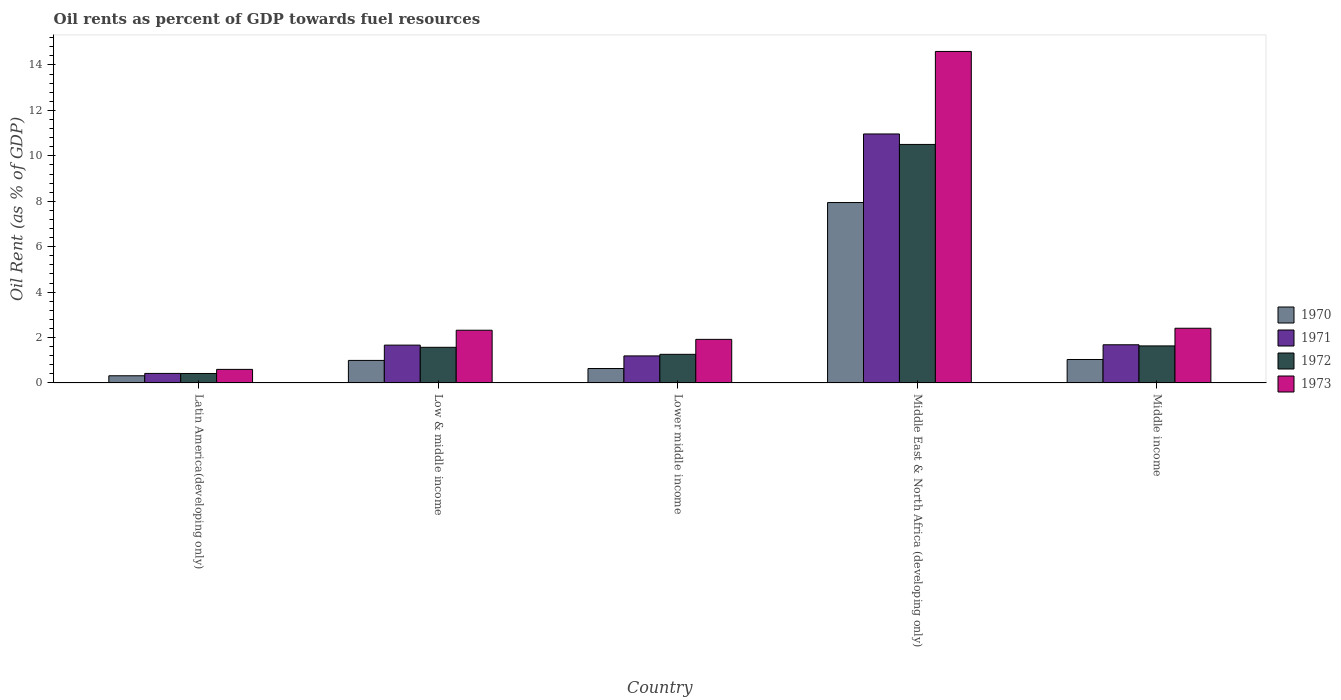How many different coloured bars are there?
Ensure brevity in your answer.  4. Are the number of bars per tick equal to the number of legend labels?
Provide a succinct answer. Yes. Are the number of bars on each tick of the X-axis equal?
Ensure brevity in your answer.  Yes. How many bars are there on the 3rd tick from the left?
Provide a succinct answer. 4. How many bars are there on the 5th tick from the right?
Ensure brevity in your answer.  4. What is the label of the 2nd group of bars from the left?
Your answer should be compact. Low & middle income. What is the oil rent in 1970 in Lower middle income?
Your response must be concise. 0.63. Across all countries, what is the maximum oil rent in 1972?
Keep it short and to the point. 10.5. Across all countries, what is the minimum oil rent in 1971?
Offer a terse response. 0.42. In which country was the oil rent in 1973 maximum?
Provide a short and direct response. Middle East & North Africa (developing only). In which country was the oil rent in 1971 minimum?
Give a very brief answer. Latin America(developing only). What is the total oil rent in 1970 in the graph?
Your response must be concise. 10.92. What is the difference between the oil rent in 1973 in Lower middle income and that in Middle income?
Offer a terse response. -0.49. What is the difference between the oil rent in 1971 in Middle East & North Africa (developing only) and the oil rent in 1972 in Latin America(developing only)?
Ensure brevity in your answer.  10.55. What is the average oil rent in 1972 per country?
Your answer should be very brief. 3.08. What is the difference between the oil rent of/in 1971 and oil rent of/in 1972 in Latin America(developing only)?
Offer a terse response. 0. What is the ratio of the oil rent in 1973 in Lower middle income to that in Middle income?
Give a very brief answer. 0.8. Is the difference between the oil rent in 1971 in Low & middle income and Middle East & North Africa (developing only) greater than the difference between the oil rent in 1972 in Low & middle income and Middle East & North Africa (developing only)?
Make the answer very short. No. What is the difference between the highest and the second highest oil rent in 1971?
Your answer should be very brief. -9.28. What is the difference between the highest and the lowest oil rent in 1973?
Your answer should be very brief. 14. What does the 1st bar from the right in Middle East & North Africa (developing only) represents?
Give a very brief answer. 1973. Are all the bars in the graph horizontal?
Your response must be concise. No. Does the graph contain any zero values?
Your response must be concise. No. Where does the legend appear in the graph?
Your answer should be very brief. Center right. How are the legend labels stacked?
Ensure brevity in your answer.  Vertical. What is the title of the graph?
Offer a terse response. Oil rents as percent of GDP towards fuel resources. Does "2003" appear as one of the legend labels in the graph?
Keep it short and to the point. No. What is the label or title of the Y-axis?
Offer a very short reply. Oil Rent (as % of GDP). What is the Oil Rent (as % of GDP) of 1970 in Latin America(developing only)?
Your answer should be very brief. 0.32. What is the Oil Rent (as % of GDP) of 1971 in Latin America(developing only)?
Your response must be concise. 0.42. What is the Oil Rent (as % of GDP) in 1972 in Latin America(developing only)?
Offer a terse response. 0.42. What is the Oil Rent (as % of GDP) of 1973 in Latin America(developing only)?
Make the answer very short. 0.6. What is the Oil Rent (as % of GDP) in 1970 in Low & middle income?
Provide a succinct answer. 0.99. What is the Oil Rent (as % of GDP) in 1971 in Low & middle income?
Your response must be concise. 1.67. What is the Oil Rent (as % of GDP) of 1972 in Low & middle income?
Keep it short and to the point. 1.57. What is the Oil Rent (as % of GDP) of 1973 in Low & middle income?
Your response must be concise. 2.32. What is the Oil Rent (as % of GDP) of 1970 in Lower middle income?
Provide a short and direct response. 0.63. What is the Oil Rent (as % of GDP) in 1971 in Lower middle income?
Provide a short and direct response. 1.19. What is the Oil Rent (as % of GDP) of 1972 in Lower middle income?
Give a very brief answer. 1.26. What is the Oil Rent (as % of GDP) of 1973 in Lower middle income?
Offer a terse response. 1.92. What is the Oil Rent (as % of GDP) in 1970 in Middle East & North Africa (developing only)?
Your response must be concise. 7.94. What is the Oil Rent (as % of GDP) in 1971 in Middle East & North Africa (developing only)?
Make the answer very short. 10.96. What is the Oil Rent (as % of GDP) of 1972 in Middle East & North Africa (developing only)?
Offer a very short reply. 10.5. What is the Oil Rent (as % of GDP) in 1973 in Middle East & North Africa (developing only)?
Offer a terse response. 14.6. What is the Oil Rent (as % of GDP) in 1970 in Middle income?
Make the answer very short. 1.03. What is the Oil Rent (as % of GDP) of 1971 in Middle income?
Give a very brief answer. 1.68. What is the Oil Rent (as % of GDP) in 1972 in Middle income?
Give a very brief answer. 1.63. What is the Oil Rent (as % of GDP) of 1973 in Middle income?
Make the answer very short. 2.41. Across all countries, what is the maximum Oil Rent (as % of GDP) in 1970?
Your response must be concise. 7.94. Across all countries, what is the maximum Oil Rent (as % of GDP) in 1971?
Your answer should be compact. 10.96. Across all countries, what is the maximum Oil Rent (as % of GDP) in 1972?
Offer a terse response. 10.5. Across all countries, what is the maximum Oil Rent (as % of GDP) in 1973?
Offer a very short reply. 14.6. Across all countries, what is the minimum Oil Rent (as % of GDP) of 1970?
Offer a terse response. 0.32. Across all countries, what is the minimum Oil Rent (as % of GDP) in 1971?
Give a very brief answer. 0.42. Across all countries, what is the minimum Oil Rent (as % of GDP) of 1972?
Offer a terse response. 0.42. Across all countries, what is the minimum Oil Rent (as % of GDP) in 1973?
Your answer should be compact. 0.6. What is the total Oil Rent (as % of GDP) of 1970 in the graph?
Your answer should be very brief. 10.92. What is the total Oil Rent (as % of GDP) of 1971 in the graph?
Ensure brevity in your answer.  15.92. What is the total Oil Rent (as % of GDP) in 1972 in the graph?
Provide a short and direct response. 15.38. What is the total Oil Rent (as % of GDP) of 1973 in the graph?
Offer a very short reply. 21.84. What is the difference between the Oil Rent (as % of GDP) of 1970 in Latin America(developing only) and that in Low & middle income?
Make the answer very short. -0.68. What is the difference between the Oil Rent (as % of GDP) of 1971 in Latin America(developing only) and that in Low & middle income?
Keep it short and to the point. -1.25. What is the difference between the Oil Rent (as % of GDP) of 1972 in Latin America(developing only) and that in Low & middle income?
Your answer should be compact. -1.15. What is the difference between the Oil Rent (as % of GDP) in 1973 in Latin America(developing only) and that in Low & middle income?
Ensure brevity in your answer.  -1.72. What is the difference between the Oil Rent (as % of GDP) of 1970 in Latin America(developing only) and that in Lower middle income?
Your answer should be very brief. -0.32. What is the difference between the Oil Rent (as % of GDP) in 1971 in Latin America(developing only) and that in Lower middle income?
Make the answer very short. -0.77. What is the difference between the Oil Rent (as % of GDP) of 1972 in Latin America(developing only) and that in Lower middle income?
Keep it short and to the point. -0.84. What is the difference between the Oil Rent (as % of GDP) of 1973 in Latin America(developing only) and that in Lower middle income?
Offer a very short reply. -1.32. What is the difference between the Oil Rent (as % of GDP) in 1970 in Latin America(developing only) and that in Middle East & North Africa (developing only)?
Your answer should be compact. -7.63. What is the difference between the Oil Rent (as % of GDP) in 1971 in Latin America(developing only) and that in Middle East & North Africa (developing only)?
Your response must be concise. -10.54. What is the difference between the Oil Rent (as % of GDP) in 1972 in Latin America(developing only) and that in Middle East & North Africa (developing only)?
Offer a terse response. -10.09. What is the difference between the Oil Rent (as % of GDP) in 1973 in Latin America(developing only) and that in Middle East & North Africa (developing only)?
Ensure brevity in your answer.  -14. What is the difference between the Oil Rent (as % of GDP) of 1970 in Latin America(developing only) and that in Middle income?
Your answer should be compact. -0.72. What is the difference between the Oil Rent (as % of GDP) of 1971 in Latin America(developing only) and that in Middle income?
Offer a very short reply. -1.26. What is the difference between the Oil Rent (as % of GDP) of 1972 in Latin America(developing only) and that in Middle income?
Keep it short and to the point. -1.21. What is the difference between the Oil Rent (as % of GDP) of 1973 in Latin America(developing only) and that in Middle income?
Your response must be concise. -1.81. What is the difference between the Oil Rent (as % of GDP) of 1970 in Low & middle income and that in Lower middle income?
Give a very brief answer. 0.36. What is the difference between the Oil Rent (as % of GDP) in 1971 in Low & middle income and that in Lower middle income?
Your response must be concise. 0.48. What is the difference between the Oil Rent (as % of GDP) in 1972 in Low & middle income and that in Lower middle income?
Provide a short and direct response. 0.31. What is the difference between the Oil Rent (as % of GDP) of 1973 in Low & middle income and that in Lower middle income?
Your answer should be compact. 0.4. What is the difference between the Oil Rent (as % of GDP) of 1970 in Low & middle income and that in Middle East & North Africa (developing only)?
Offer a terse response. -6.95. What is the difference between the Oil Rent (as % of GDP) in 1971 in Low & middle income and that in Middle East & North Africa (developing only)?
Make the answer very short. -9.3. What is the difference between the Oil Rent (as % of GDP) in 1972 in Low & middle income and that in Middle East & North Africa (developing only)?
Your answer should be very brief. -8.93. What is the difference between the Oil Rent (as % of GDP) in 1973 in Low & middle income and that in Middle East & North Africa (developing only)?
Make the answer very short. -12.28. What is the difference between the Oil Rent (as % of GDP) in 1970 in Low & middle income and that in Middle income?
Your response must be concise. -0.04. What is the difference between the Oil Rent (as % of GDP) of 1971 in Low & middle income and that in Middle income?
Keep it short and to the point. -0.01. What is the difference between the Oil Rent (as % of GDP) of 1972 in Low & middle income and that in Middle income?
Your response must be concise. -0.06. What is the difference between the Oil Rent (as % of GDP) of 1973 in Low & middle income and that in Middle income?
Keep it short and to the point. -0.09. What is the difference between the Oil Rent (as % of GDP) in 1970 in Lower middle income and that in Middle East & North Africa (developing only)?
Your answer should be compact. -7.31. What is the difference between the Oil Rent (as % of GDP) in 1971 in Lower middle income and that in Middle East & North Africa (developing only)?
Your answer should be compact. -9.77. What is the difference between the Oil Rent (as % of GDP) of 1972 in Lower middle income and that in Middle East & North Africa (developing only)?
Make the answer very short. -9.24. What is the difference between the Oil Rent (as % of GDP) in 1973 in Lower middle income and that in Middle East & North Africa (developing only)?
Give a very brief answer. -12.68. What is the difference between the Oil Rent (as % of GDP) in 1970 in Lower middle income and that in Middle income?
Your answer should be very brief. -0.4. What is the difference between the Oil Rent (as % of GDP) of 1971 in Lower middle income and that in Middle income?
Offer a very short reply. -0.49. What is the difference between the Oil Rent (as % of GDP) of 1972 in Lower middle income and that in Middle income?
Provide a succinct answer. -0.37. What is the difference between the Oil Rent (as % of GDP) of 1973 in Lower middle income and that in Middle income?
Your answer should be compact. -0.49. What is the difference between the Oil Rent (as % of GDP) of 1970 in Middle East & North Africa (developing only) and that in Middle income?
Provide a short and direct response. 6.91. What is the difference between the Oil Rent (as % of GDP) of 1971 in Middle East & North Africa (developing only) and that in Middle income?
Ensure brevity in your answer.  9.28. What is the difference between the Oil Rent (as % of GDP) of 1972 in Middle East & North Africa (developing only) and that in Middle income?
Provide a succinct answer. 8.87. What is the difference between the Oil Rent (as % of GDP) in 1973 in Middle East & North Africa (developing only) and that in Middle income?
Give a very brief answer. 12.19. What is the difference between the Oil Rent (as % of GDP) in 1970 in Latin America(developing only) and the Oil Rent (as % of GDP) in 1971 in Low & middle income?
Provide a short and direct response. -1.35. What is the difference between the Oil Rent (as % of GDP) in 1970 in Latin America(developing only) and the Oil Rent (as % of GDP) in 1972 in Low & middle income?
Your answer should be very brief. -1.25. What is the difference between the Oil Rent (as % of GDP) in 1970 in Latin America(developing only) and the Oil Rent (as % of GDP) in 1973 in Low & middle income?
Your answer should be compact. -2.01. What is the difference between the Oil Rent (as % of GDP) in 1971 in Latin America(developing only) and the Oil Rent (as % of GDP) in 1972 in Low & middle income?
Your response must be concise. -1.15. What is the difference between the Oil Rent (as % of GDP) of 1971 in Latin America(developing only) and the Oil Rent (as % of GDP) of 1973 in Low & middle income?
Provide a succinct answer. -1.9. What is the difference between the Oil Rent (as % of GDP) of 1972 in Latin America(developing only) and the Oil Rent (as % of GDP) of 1973 in Low & middle income?
Provide a succinct answer. -1.9. What is the difference between the Oil Rent (as % of GDP) of 1970 in Latin America(developing only) and the Oil Rent (as % of GDP) of 1971 in Lower middle income?
Ensure brevity in your answer.  -0.87. What is the difference between the Oil Rent (as % of GDP) of 1970 in Latin America(developing only) and the Oil Rent (as % of GDP) of 1972 in Lower middle income?
Provide a short and direct response. -0.94. What is the difference between the Oil Rent (as % of GDP) of 1970 in Latin America(developing only) and the Oil Rent (as % of GDP) of 1973 in Lower middle income?
Keep it short and to the point. -1.6. What is the difference between the Oil Rent (as % of GDP) of 1971 in Latin America(developing only) and the Oil Rent (as % of GDP) of 1972 in Lower middle income?
Give a very brief answer. -0.84. What is the difference between the Oil Rent (as % of GDP) in 1971 in Latin America(developing only) and the Oil Rent (as % of GDP) in 1973 in Lower middle income?
Keep it short and to the point. -1.5. What is the difference between the Oil Rent (as % of GDP) of 1972 in Latin America(developing only) and the Oil Rent (as % of GDP) of 1973 in Lower middle income?
Make the answer very short. -1.5. What is the difference between the Oil Rent (as % of GDP) of 1970 in Latin America(developing only) and the Oil Rent (as % of GDP) of 1971 in Middle East & North Africa (developing only)?
Your response must be concise. -10.65. What is the difference between the Oil Rent (as % of GDP) of 1970 in Latin America(developing only) and the Oil Rent (as % of GDP) of 1972 in Middle East & North Africa (developing only)?
Offer a very short reply. -10.19. What is the difference between the Oil Rent (as % of GDP) of 1970 in Latin America(developing only) and the Oil Rent (as % of GDP) of 1973 in Middle East & North Africa (developing only)?
Offer a very short reply. -14.28. What is the difference between the Oil Rent (as % of GDP) of 1971 in Latin America(developing only) and the Oil Rent (as % of GDP) of 1972 in Middle East & North Africa (developing only)?
Your answer should be compact. -10.08. What is the difference between the Oil Rent (as % of GDP) of 1971 in Latin America(developing only) and the Oil Rent (as % of GDP) of 1973 in Middle East & North Africa (developing only)?
Provide a succinct answer. -14.18. What is the difference between the Oil Rent (as % of GDP) in 1972 in Latin America(developing only) and the Oil Rent (as % of GDP) in 1973 in Middle East & North Africa (developing only)?
Provide a short and direct response. -14.18. What is the difference between the Oil Rent (as % of GDP) in 1970 in Latin America(developing only) and the Oil Rent (as % of GDP) in 1971 in Middle income?
Make the answer very short. -1.36. What is the difference between the Oil Rent (as % of GDP) of 1970 in Latin America(developing only) and the Oil Rent (as % of GDP) of 1972 in Middle income?
Your answer should be very brief. -1.32. What is the difference between the Oil Rent (as % of GDP) in 1970 in Latin America(developing only) and the Oil Rent (as % of GDP) in 1973 in Middle income?
Your answer should be very brief. -2.09. What is the difference between the Oil Rent (as % of GDP) of 1971 in Latin America(developing only) and the Oil Rent (as % of GDP) of 1972 in Middle income?
Give a very brief answer. -1.21. What is the difference between the Oil Rent (as % of GDP) of 1971 in Latin America(developing only) and the Oil Rent (as % of GDP) of 1973 in Middle income?
Provide a short and direct response. -1.99. What is the difference between the Oil Rent (as % of GDP) in 1972 in Latin America(developing only) and the Oil Rent (as % of GDP) in 1973 in Middle income?
Make the answer very short. -1.99. What is the difference between the Oil Rent (as % of GDP) in 1970 in Low & middle income and the Oil Rent (as % of GDP) in 1971 in Lower middle income?
Ensure brevity in your answer.  -0.2. What is the difference between the Oil Rent (as % of GDP) of 1970 in Low & middle income and the Oil Rent (as % of GDP) of 1972 in Lower middle income?
Provide a short and direct response. -0.27. What is the difference between the Oil Rent (as % of GDP) in 1970 in Low & middle income and the Oil Rent (as % of GDP) in 1973 in Lower middle income?
Give a very brief answer. -0.93. What is the difference between the Oil Rent (as % of GDP) in 1971 in Low & middle income and the Oil Rent (as % of GDP) in 1972 in Lower middle income?
Offer a very short reply. 0.41. What is the difference between the Oil Rent (as % of GDP) in 1971 in Low & middle income and the Oil Rent (as % of GDP) in 1973 in Lower middle income?
Provide a short and direct response. -0.25. What is the difference between the Oil Rent (as % of GDP) in 1972 in Low & middle income and the Oil Rent (as % of GDP) in 1973 in Lower middle income?
Your answer should be very brief. -0.35. What is the difference between the Oil Rent (as % of GDP) of 1970 in Low & middle income and the Oil Rent (as % of GDP) of 1971 in Middle East & North Africa (developing only)?
Ensure brevity in your answer.  -9.97. What is the difference between the Oil Rent (as % of GDP) in 1970 in Low & middle income and the Oil Rent (as % of GDP) in 1972 in Middle East & North Africa (developing only)?
Your answer should be compact. -9.51. What is the difference between the Oil Rent (as % of GDP) of 1970 in Low & middle income and the Oil Rent (as % of GDP) of 1973 in Middle East & North Africa (developing only)?
Give a very brief answer. -13.6. What is the difference between the Oil Rent (as % of GDP) in 1971 in Low & middle income and the Oil Rent (as % of GDP) in 1972 in Middle East & North Africa (developing only)?
Your answer should be very brief. -8.84. What is the difference between the Oil Rent (as % of GDP) in 1971 in Low & middle income and the Oil Rent (as % of GDP) in 1973 in Middle East & North Africa (developing only)?
Your response must be concise. -12.93. What is the difference between the Oil Rent (as % of GDP) in 1972 in Low & middle income and the Oil Rent (as % of GDP) in 1973 in Middle East & North Africa (developing only)?
Offer a terse response. -13.03. What is the difference between the Oil Rent (as % of GDP) in 1970 in Low & middle income and the Oil Rent (as % of GDP) in 1971 in Middle income?
Your answer should be very brief. -0.69. What is the difference between the Oil Rent (as % of GDP) of 1970 in Low & middle income and the Oil Rent (as % of GDP) of 1972 in Middle income?
Ensure brevity in your answer.  -0.64. What is the difference between the Oil Rent (as % of GDP) of 1970 in Low & middle income and the Oil Rent (as % of GDP) of 1973 in Middle income?
Your answer should be very brief. -1.42. What is the difference between the Oil Rent (as % of GDP) of 1971 in Low & middle income and the Oil Rent (as % of GDP) of 1972 in Middle income?
Offer a very short reply. 0.03. What is the difference between the Oil Rent (as % of GDP) of 1971 in Low & middle income and the Oil Rent (as % of GDP) of 1973 in Middle income?
Ensure brevity in your answer.  -0.74. What is the difference between the Oil Rent (as % of GDP) of 1972 in Low & middle income and the Oil Rent (as % of GDP) of 1973 in Middle income?
Ensure brevity in your answer.  -0.84. What is the difference between the Oil Rent (as % of GDP) in 1970 in Lower middle income and the Oil Rent (as % of GDP) in 1971 in Middle East & North Africa (developing only)?
Provide a succinct answer. -10.33. What is the difference between the Oil Rent (as % of GDP) in 1970 in Lower middle income and the Oil Rent (as % of GDP) in 1972 in Middle East & North Africa (developing only)?
Your answer should be very brief. -9.87. What is the difference between the Oil Rent (as % of GDP) of 1970 in Lower middle income and the Oil Rent (as % of GDP) of 1973 in Middle East & North Africa (developing only)?
Your answer should be compact. -13.96. What is the difference between the Oil Rent (as % of GDP) in 1971 in Lower middle income and the Oil Rent (as % of GDP) in 1972 in Middle East & North Africa (developing only)?
Provide a short and direct response. -9.31. What is the difference between the Oil Rent (as % of GDP) in 1971 in Lower middle income and the Oil Rent (as % of GDP) in 1973 in Middle East & North Africa (developing only)?
Provide a short and direct response. -13.41. What is the difference between the Oil Rent (as % of GDP) of 1972 in Lower middle income and the Oil Rent (as % of GDP) of 1973 in Middle East & North Africa (developing only)?
Ensure brevity in your answer.  -13.34. What is the difference between the Oil Rent (as % of GDP) in 1970 in Lower middle income and the Oil Rent (as % of GDP) in 1971 in Middle income?
Offer a terse response. -1.05. What is the difference between the Oil Rent (as % of GDP) in 1970 in Lower middle income and the Oil Rent (as % of GDP) in 1972 in Middle income?
Provide a short and direct response. -1. What is the difference between the Oil Rent (as % of GDP) in 1970 in Lower middle income and the Oil Rent (as % of GDP) in 1973 in Middle income?
Offer a very short reply. -1.77. What is the difference between the Oil Rent (as % of GDP) in 1971 in Lower middle income and the Oil Rent (as % of GDP) in 1972 in Middle income?
Provide a succinct answer. -0.44. What is the difference between the Oil Rent (as % of GDP) in 1971 in Lower middle income and the Oil Rent (as % of GDP) in 1973 in Middle income?
Make the answer very short. -1.22. What is the difference between the Oil Rent (as % of GDP) in 1972 in Lower middle income and the Oil Rent (as % of GDP) in 1973 in Middle income?
Provide a short and direct response. -1.15. What is the difference between the Oil Rent (as % of GDP) of 1970 in Middle East & North Africa (developing only) and the Oil Rent (as % of GDP) of 1971 in Middle income?
Your response must be concise. 6.26. What is the difference between the Oil Rent (as % of GDP) of 1970 in Middle East & North Africa (developing only) and the Oil Rent (as % of GDP) of 1972 in Middle income?
Your answer should be compact. 6.31. What is the difference between the Oil Rent (as % of GDP) in 1970 in Middle East & North Africa (developing only) and the Oil Rent (as % of GDP) in 1973 in Middle income?
Your response must be concise. 5.53. What is the difference between the Oil Rent (as % of GDP) in 1971 in Middle East & North Africa (developing only) and the Oil Rent (as % of GDP) in 1972 in Middle income?
Give a very brief answer. 9.33. What is the difference between the Oil Rent (as % of GDP) of 1971 in Middle East & North Africa (developing only) and the Oil Rent (as % of GDP) of 1973 in Middle income?
Provide a succinct answer. 8.55. What is the difference between the Oil Rent (as % of GDP) of 1972 in Middle East & North Africa (developing only) and the Oil Rent (as % of GDP) of 1973 in Middle income?
Make the answer very short. 8.09. What is the average Oil Rent (as % of GDP) of 1970 per country?
Your answer should be compact. 2.18. What is the average Oil Rent (as % of GDP) of 1971 per country?
Offer a very short reply. 3.18. What is the average Oil Rent (as % of GDP) of 1972 per country?
Offer a very short reply. 3.08. What is the average Oil Rent (as % of GDP) of 1973 per country?
Keep it short and to the point. 4.37. What is the difference between the Oil Rent (as % of GDP) of 1970 and Oil Rent (as % of GDP) of 1971 in Latin America(developing only)?
Offer a very short reply. -0.1. What is the difference between the Oil Rent (as % of GDP) in 1970 and Oil Rent (as % of GDP) in 1972 in Latin America(developing only)?
Make the answer very short. -0.1. What is the difference between the Oil Rent (as % of GDP) of 1970 and Oil Rent (as % of GDP) of 1973 in Latin America(developing only)?
Your answer should be compact. -0.28. What is the difference between the Oil Rent (as % of GDP) in 1971 and Oil Rent (as % of GDP) in 1972 in Latin America(developing only)?
Make the answer very short. 0. What is the difference between the Oil Rent (as % of GDP) of 1971 and Oil Rent (as % of GDP) of 1973 in Latin America(developing only)?
Make the answer very short. -0.18. What is the difference between the Oil Rent (as % of GDP) in 1972 and Oil Rent (as % of GDP) in 1973 in Latin America(developing only)?
Your answer should be very brief. -0.18. What is the difference between the Oil Rent (as % of GDP) in 1970 and Oil Rent (as % of GDP) in 1971 in Low & middle income?
Provide a short and direct response. -0.67. What is the difference between the Oil Rent (as % of GDP) in 1970 and Oil Rent (as % of GDP) in 1972 in Low & middle income?
Ensure brevity in your answer.  -0.58. What is the difference between the Oil Rent (as % of GDP) of 1970 and Oil Rent (as % of GDP) of 1973 in Low & middle income?
Offer a very short reply. -1.33. What is the difference between the Oil Rent (as % of GDP) in 1971 and Oil Rent (as % of GDP) in 1972 in Low & middle income?
Your answer should be compact. 0.1. What is the difference between the Oil Rent (as % of GDP) in 1971 and Oil Rent (as % of GDP) in 1973 in Low & middle income?
Your response must be concise. -0.66. What is the difference between the Oil Rent (as % of GDP) of 1972 and Oil Rent (as % of GDP) of 1973 in Low & middle income?
Keep it short and to the point. -0.75. What is the difference between the Oil Rent (as % of GDP) of 1970 and Oil Rent (as % of GDP) of 1971 in Lower middle income?
Your answer should be compact. -0.56. What is the difference between the Oil Rent (as % of GDP) in 1970 and Oil Rent (as % of GDP) in 1972 in Lower middle income?
Provide a succinct answer. -0.62. What is the difference between the Oil Rent (as % of GDP) of 1970 and Oil Rent (as % of GDP) of 1973 in Lower middle income?
Your answer should be very brief. -1.28. What is the difference between the Oil Rent (as % of GDP) in 1971 and Oil Rent (as % of GDP) in 1972 in Lower middle income?
Provide a short and direct response. -0.07. What is the difference between the Oil Rent (as % of GDP) in 1971 and Oil Rent (as % of GDP) in 1973 in Lower middle income?
Your response must be concise. -0.73. What is the difference between the Oil Rent (as % of GDP) of 1972 and Oil Rent (as % of GDP) of 1973 in Lower middle income?
Offer a terse response. -0.66. What is the difference between the Oil Rent (as % of GDP) in 1970 and Oil Rent (as % of GDP) in 1971 in Middle East & North Africa (developing only)?
Your response must be concise. -3.02. What is the difference between the Oil Rent (as % of GDP) of 1970 and Oil Rent (as % of GDP) of 1972 in Middle East & North Africa (developing only)?
Keep it short and to the point. -2.56. What is the difference between the Oil Rent (as % of GDP) in 1970 and Oil Rent (as % of GDP) in 1973 in Middle East & North Africa (developing only)?
Give a very brief answer. -6.65. What is the difference between the Oil Rent (as % of GDP) in 1971 and Oil Rent (as % of GDP) in 1972 in Middle East & North Africa (developing only)?
Your answer should be compact. 0.46. What is the difference between the Oil Rent (as % of GDP) of 1971 and Oil Rent (as % of GDP) of 1973 in Middle East & North Africa (developing only)?
Provide a short and direct response. -3.63. What is the difference between the Oil Rent (as % of GDP) in 1972 and Oil Rent (as % of GDP) in 1973 in Middle East & North Africa (developing only)?
Keep it short and to the point. -4.09. What is the difference between the Oil Rent (as % of GDP) of 1970 and Oil Rent (as % of GDP) of 1971 in Middle income?
Provide a succinct answer. -0.65. What is the difference between the Oil Rent (as % of GDP) of 1970 and Oil Rent (as % of GDP) of 1972 in Middle income?
Ensure brevity in your answer.  -0.6. What is the difference between the Oil Rent (as % of GDP) in 1970 and Oil Rent (as % of GDP) in 1973 in Middle income?
Keep it short and to the point. -1.38. What is the difference between the Oil Rent (as % of GDP) of 1971 and Oil Rent (as % of GDP) of 1972 in Middle income?
Provide a short and direct response. 0.05. What is the difference between the Oil Rent (as % of GDP) in 1971 and Oil Rent (as % of GDP) in 1973 in Middle income?
Make the answer very short. -0.73. What is the difference between the Oil Rent (as % of GDP) in 1972 and Oil Rent (as % of GDP) in 1973 in Middle income?
Your response must be concise. -0.78. What is the ratio of the Oil Rent (as % of GDP) in 1970 in Latin America(developing only) to that in Low & middle income?
Keep it short and to the point. 0.32. What is the ratio of the Oil Rent (as % of GDP) in 1971 in Latin America(developing only) to that in Low & middle income?
Give a very brief answer. 0.25. What is the ratio of the Oil Rent (as % of GDP) in 1972 in Latin America(developing only) to that in Low & middle income?
Make the answer very short. 0.27. What is the ratio of the Oil Rent (as % of GDP) of 1973 in Latin America(developing only) to that in Low & middle income?
Your answer should be very brief. 0.26. What is the ratio of the Oil Rent (as % of GDP) in 1970 in Latin America(developing only) to that in Lower middle income?
Your answer should be very brief. 0.5. What is the ratio of the Oil Rent (as % of GDP) in 1971 in Latin America(developing only) to that in Lower middle income?
Offer a very short reply. 0.35. What is the ratio of the Oil Rent (as % of GDP) in 1972 in Latin America(developing only) to that in Lower middle income?
Offer a very short reply. 0.33. What is the ratio of the Oil Rent (as % of GDP) in 1973 in Latin America(developing only) to that in Lower middle income?
Provide a succinct answer. 0.31. What is the ratio of the Oil Rent (as % of GDP) in 1970 in Latin America(developing only) to that in Middle East & North Africa (developing only)?
Give a very brief answer. 0.04. What is the ratio of the Oil Rent (as % of GDP) in 1971 in Latin America(developing only) to that in Middle East & North Africa (developing only)?
Your answer should be compact. 0.04. What is the ratio of the Oil Rent (as % of GDP) in 1972 in Latin America(developing only) to that in Middle East & North Africa (developing only)?
Ensure brevity in your answer.  0.04. What is the ratio of the Oil Rent (as % of GDP) of 1973 in Latin America(developing only) to that in Middle East & North Africa (developing only)?
Your answer should be very brief. 0.04. What is the ratio of the Oil Rent (as % of GDP) of 1970 in Latin America(developing only) to that in Middle income?
Offer a terse response. 0.31. What is the ratio of the Oil Rent (as % of GDP) in 1971 in Latin America(developing only) to that in Middle income?
Offer a very short reply. 0.25. What is the ratio of the Oil Rent (as % of GDP) in 1972 in Latin America(developing only) to that in Middle income?
Make the answer very short. 0.26. What is the ratio of the Oil Rent (as % of GDP) in 1973 in Latin America(developing only) to that in Middle income?
Provide a short and direct response. 0.25. What is the ratio of the Oil Rent (as % of GDP) of 1970 in Low & middle income to that in Lower middle income?
Offer a very short reply. 1.56. What is the ratio of the Oil Rent (as % of GDP) in 1971 in Low & middle income to that in Lower middle income?
Your answer should be very brief. 1.4. What is the ratio of the Oil Rent (as % of GDP) of 1972 in Low & middle income to that in Lower middle income?
Your answer should be compact. 1.25. What is the ratio of the Oil Rent (as % of GDP) in 1973 in Low & middle income to that in Lower middle income?
Offer a terse response. 1.21. What is the ratio of the Oil Rent (as % of GDP) in 1970 in Low & middle income to that in Middle East & North Africa (developing only)?
Your answer should be compact. 0.12. What is the ratio of the Oil Rent (as % of GDP) of 1971 in Low & middle income to that in Middle East & North Africa (developing only)?
Provide a short and direct response. 0.15. What is the ratio of the Oil Rent (as % of GDP) of 1972 in Low & middle income to that in Middle East & North Africa (developing only)?
Give a very brief answer. 0.15. What is the ratio of the Oil Rent (as % of GDP) of 1973 in Low & middle income to that in Middle East & North Africa (developing only)?
Your answer should be compact. 0.16. What is the ratio of the Oil Rent (as % of GDP) of 1972 in Low & middle income to that in Middle income?
Provide a succinct answer. 0.96. What is the ratio of the Oil Rent (as % of GDP) of 1973 in Low & middle income to that in Middle income?
Offer a very short reply. 0.96. What is the ratio of the Oil Rent (as % of GDP) of 1970 in Lower middle income to that in Middle East & North Africa (developing only)?
Offer a terse response. 0.08. What is the ratio of the Oil Rent (as % of GDP) of 1971 in Lower middle income to that in Middle East & North Africa (developing only)?
Ensure brevity in your answer.  0.11. What is the ratio of the Oil Rent (as % of GDP) in 1972 in Lower middle income to that in Middle East & North Africa (developing only)?
Provide a short and direct response. 0.12. What is the ratio of the Oil Rent (as % of GDP) of 1973 in Lower middle income to that in Middle East & North Africa (developing only)?
Your response must be concise. 0.13. What is the ratio of the Oil Rent (as % of GDP) of 1970 in Lower middle income to that in Middle income?
Make the answer very short. 0.61. What is the ratio of the Oil Rent (as % of GDP) of 1971 in Lower middle income to that in Middle income?
Your answer should be compact. 0.71. What is the ratio of the Oil Rent (as % of GDP) of 1972 in Lower middle income to that in Middle income?
Offer a very short reply. 0.77. What is the ratio of the Oil Rent (as % of GDP) of 1973 in Lower middle income to that in Middle income?
Keep it short and to the point. 0.8. What is the ratio of the Oil Rent (as % of GDP) in 1970 in Middle East & North Africa (developing only) to that in Middle income?
Give a very brief answer. 7.69. What is the ratio of the Oil Rent (as % of GDP) in 1971 in Middle East & North Africa (developing only) to that in Middle income?
Your response must be concise. 6.52. What is the ratio of the Oil Rent (as % of GDP) of 1972 in Middle East & North Africa (developing only) to that in Middle income?
Make the answer very short. 6.44. What is the ratio of the Oil Rent (as % of GDP) of 1973 in Middle East & North Africa (developing only) to that in Middle income?
Your response must be concise. 6.06. What is the difference between the highest and the second highest Oil Rent (as % of GDP) in 1970?
Give a very brief answer. 6.91. What is the difference between the highest and the second highest Oil Rent (as % of GDP) in 1971?
Provide a short and direct response. 9.28. What is the difference between the highest and the second highest Oil Rent (as % of GDP) of 1972?
Make the answer very short. 8.87. What is the difference between the highest and the second highest Oil Rent (as % of GDP) of 1973?
Give a very brief answer. 12.19. What is the difference between the highest and the lowest Oil Rent (as % of GDP) of 1970?
Provide a short and direct response. 7.63. What is the difference between the highest and the lowest Oil Rent (as % of GDP) in 1971?
Provide a succinct answer. 10.54. What is the difference between the highest and the lowest Oil Rent (as % of GDP) in 1972?
Your answer should be very brief. 10.09. What is the difference between the highest and the lowest Oil Rent (as % of GDP) in 1973?
Keep it short and to the point. 14. 